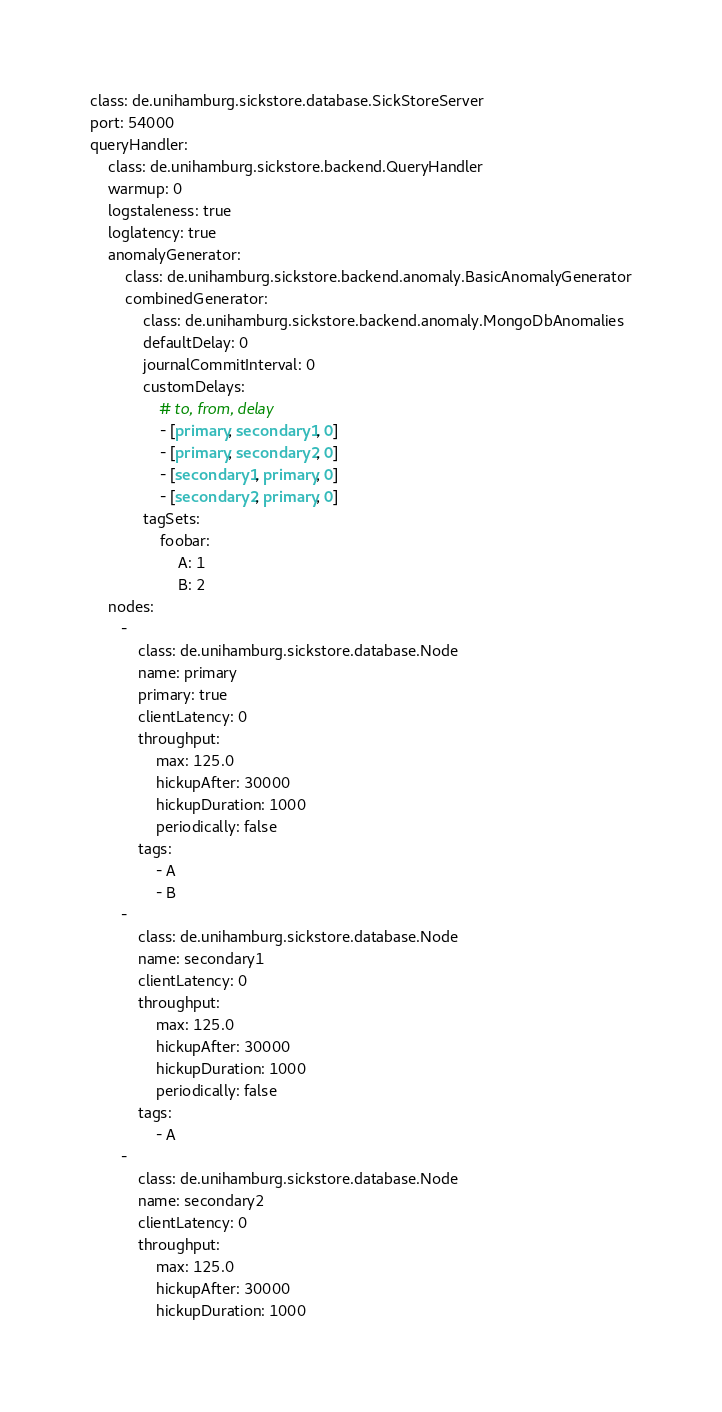<code> <loc_0><loc_0><loc_500><loc_500><_YAML_>class: de.unihamburg.sickstore.database.SickStoreServer
port: 54000
queryHandler:
    class: de.unihamburg.sickstore.backend.QueryHandler
    warmup: 0
    logstaleness: true
    loglatency: true
    anomalyGenerator:
        class: de.unihamburg.sickstore.backend.anomaly.BasicAnomalyGenerator
        combinedGenerator:
            class: de.unihamburg.sickstore.backend.anomaly.MongoDbAnomalies
            defaultDelay: 0
            journalCommitInterval: 0
            customDelays:
                # to, from, delay
                - [primary, secondary1, 0]
                - [primary, secondary2, 0]
                - [secondary1, primary, 0]
                - [secondary2, primary, 0]
            tagSets:
                foobar:
                    A: 1
                    B: 2
    nodes:
       -
           class: de.unihamburg.sickstore.database.Node
           name: primary
           primary: true
           clientLatency: 0
           throughput:
               max: 125.0
               hickupAfter: 30000
               hickupDuration: 1000
               periodically: false
           tags:
               - A
               - B
       -
           class: de.unihamburg.sickstore.database.Node
           name: secondary1
           clientLatency: 0
           throughput:
               max: 125.0
               hickupAfter: 30000
               hickupDuration: 1000
               periodically: false
           tags:
               - A
       -
           class: de.unihamburg.sickstore.database.Node
           name: secondary2
           clientLatency: 0
           throughput:
               max: 125.0
               hickupAfter: 30000
               hickupDuration: 1000</code> 